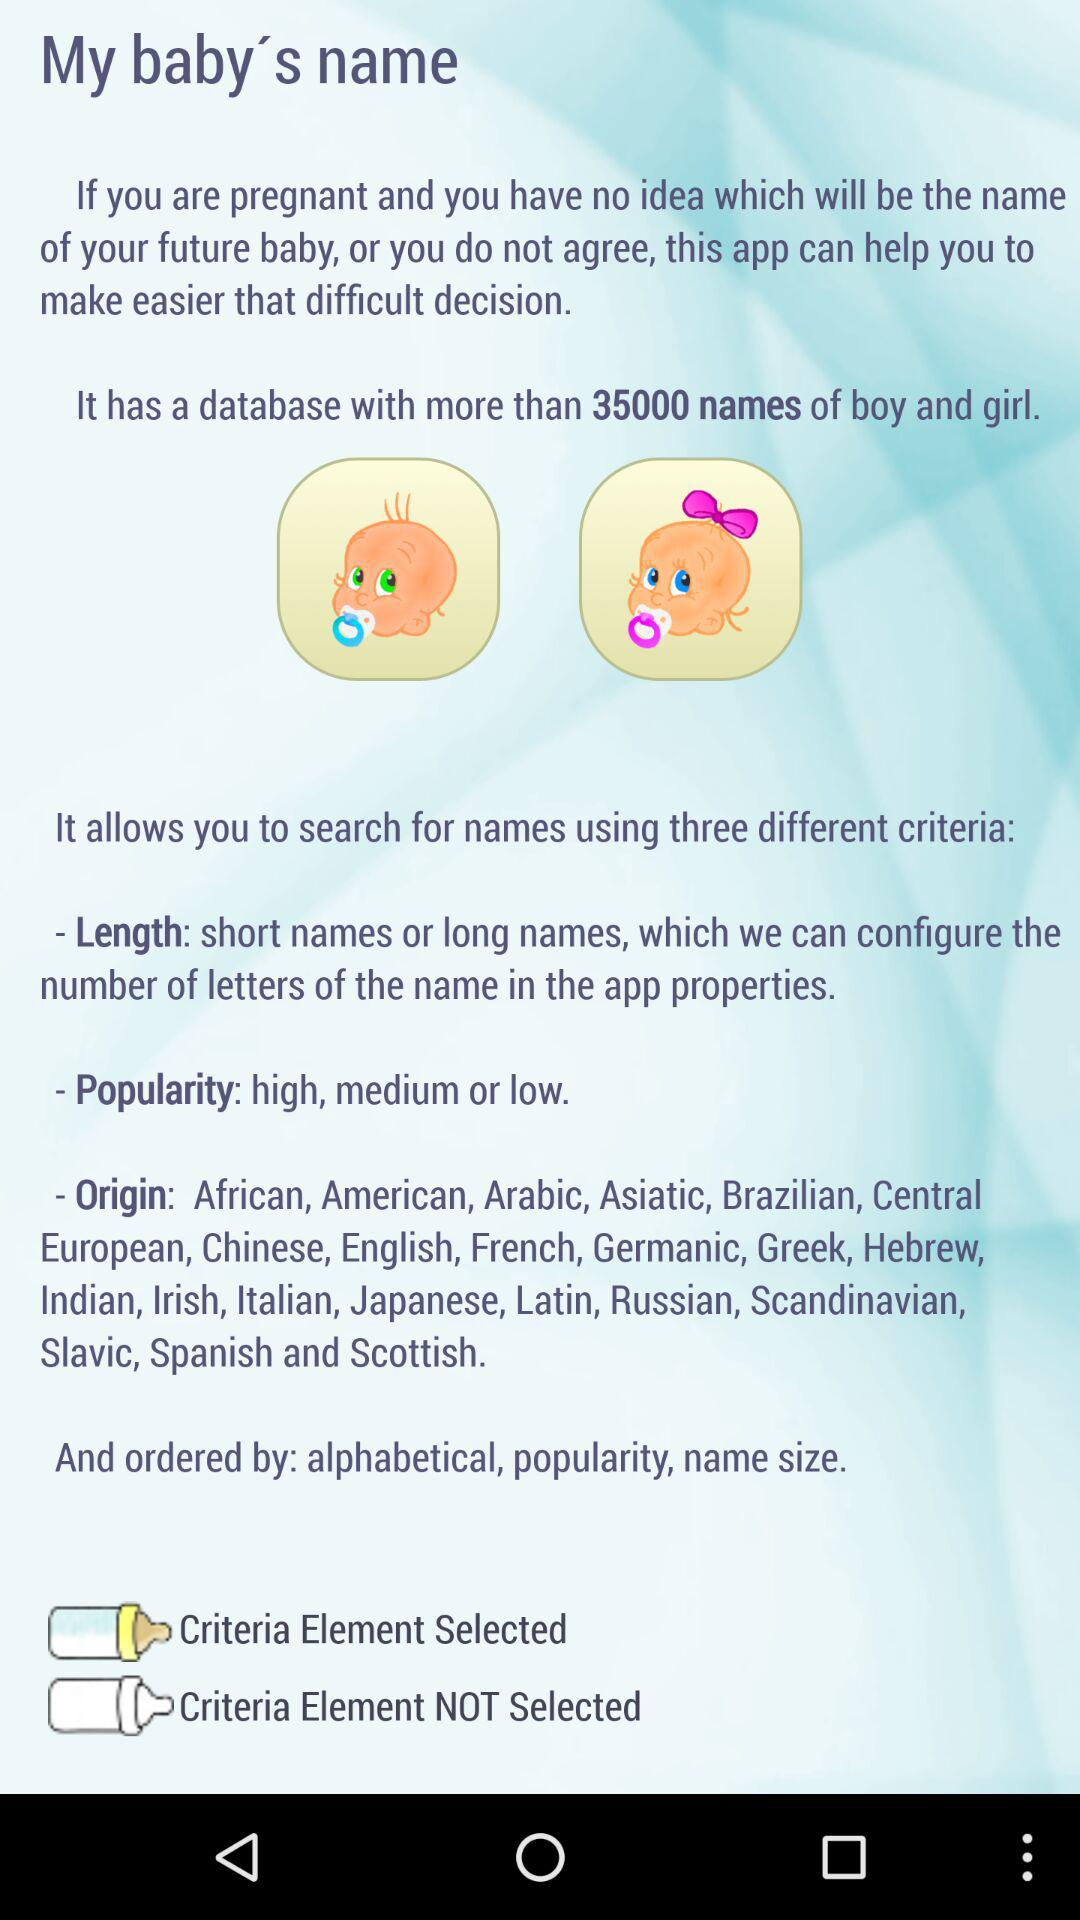How many criteria are there for searching for names?
Answer the question using a single word or phrase. 3 